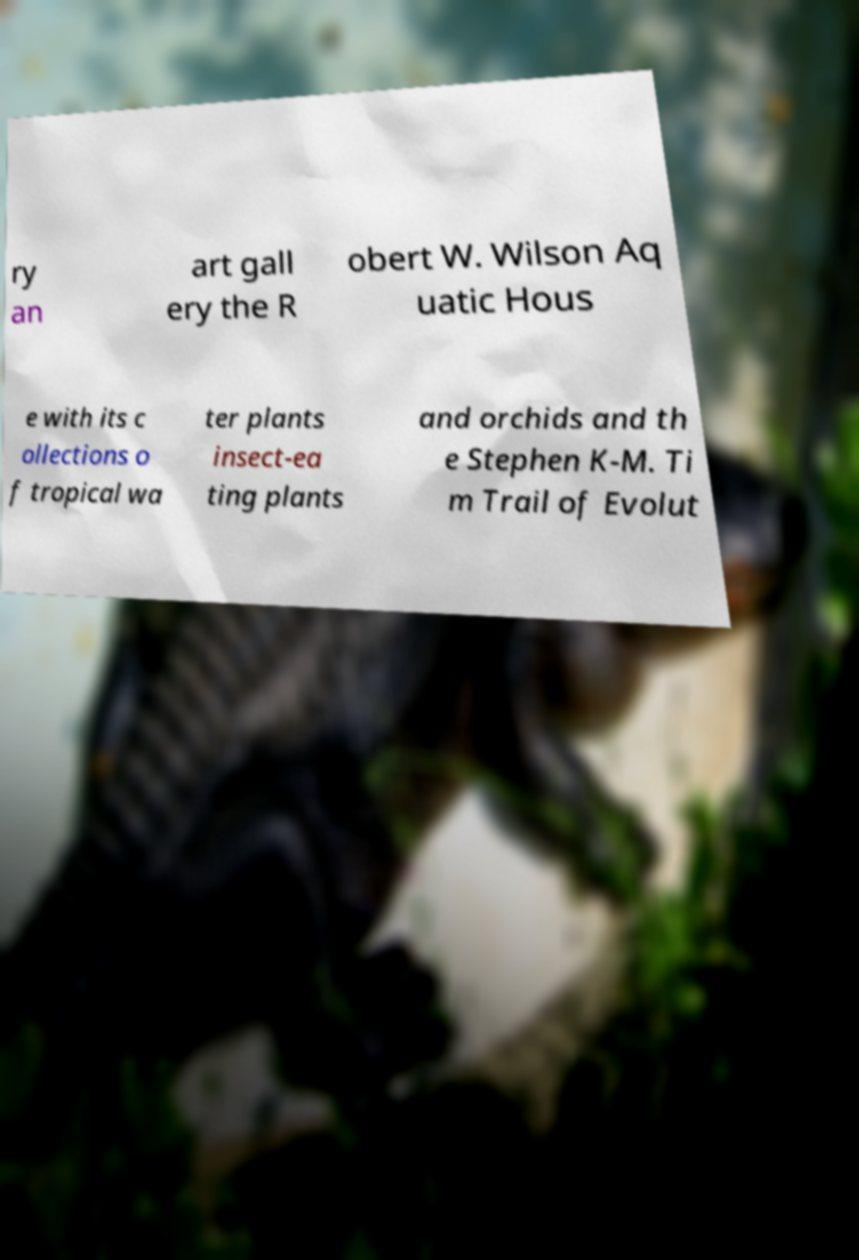What messages or text are displayed in this image? I need them in a readable, typed format. ry an art gall ery the R obert W. Wilson Aq uatic Hous e with its c ollections o f tropical wa ter plants insect-ea ting plants and orchids and th e Stephen K-M. Ti m Trail of Evolut 